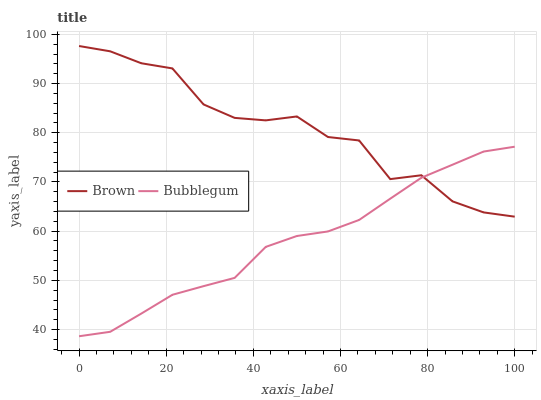Does Bubblegum have the minimum area under the curve?
Answer yes or no. Yes. Does Brown have the maximum area under the curve?
Answer yes or no. Yes. Does Bubblegum have the maximum area under the curve?
Answer yes or no. No. Is Bubblegum the smoothest?
Answer yes or no. Yes. Is Brown the roughest?
Answer yes or no. Yes. Is Bubblegum the roughest?
Answer yes or no. No. Does Bubblegum have the lowest value?
Answer yes or no. Yes. Does Brown have the highest value?
Answer yes or no. Yes. Does Bubblegum have the highest value?
Answer yes or no. No. Does Brown intersect Bubblegum?
Answer yes or no. Yes. Is Brown less than Bubblegum?
Answer yes or no. No. Is Brown greater than Bubblegum?
Answer yes or no. No. 